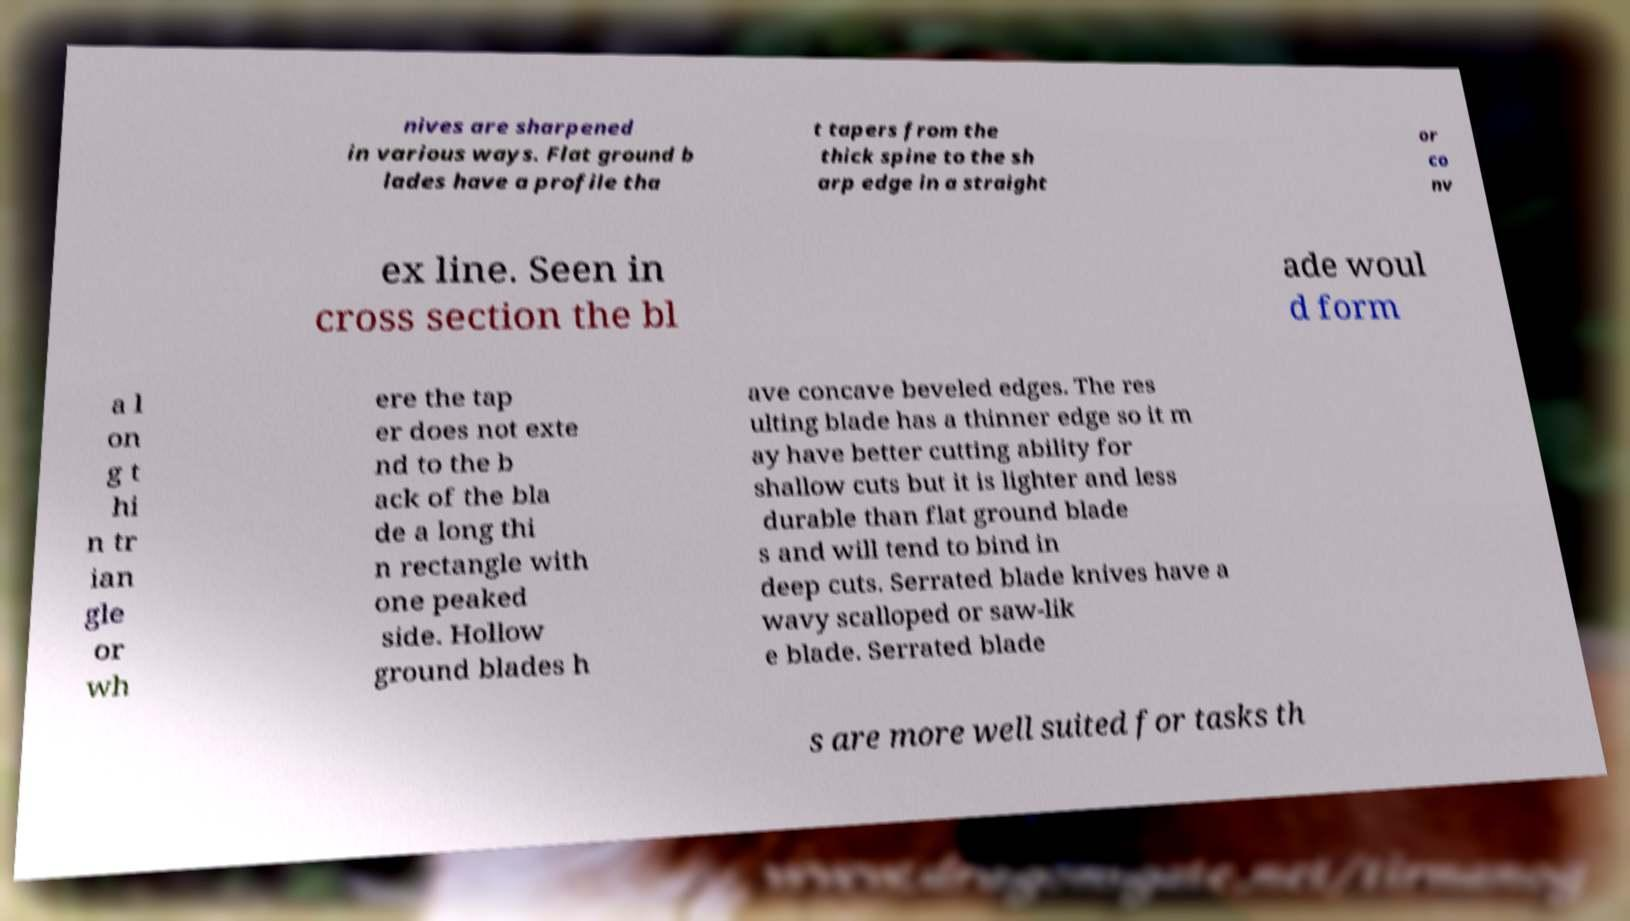For documentation purposes, I need the text within this image transcribed. Could you provide that? nives are sharpened in various ways. Flat ground b lades have a profile tha t tapers from the thick spine to the sh arp edge in a straight or co nv ex line. Seen in cross section the bl ade woul d form a l on g t hi n tr ian gle or wh ere the tap er does not exte nd to the b ack of the bla de a long thi n rectangle with one peaked side. Hollow ground blades h ave concave beveled edges. The res ulting blade has a thinner edge so it m ay have better cutting ability for shallow cuts but it is lighter and less durable than flat ground blade s and will tend to bind in deep cuts. Serrated blade knives have a wavy scalloped or saw-lik e blade. Serrated blade s are more well suited for tasks th 